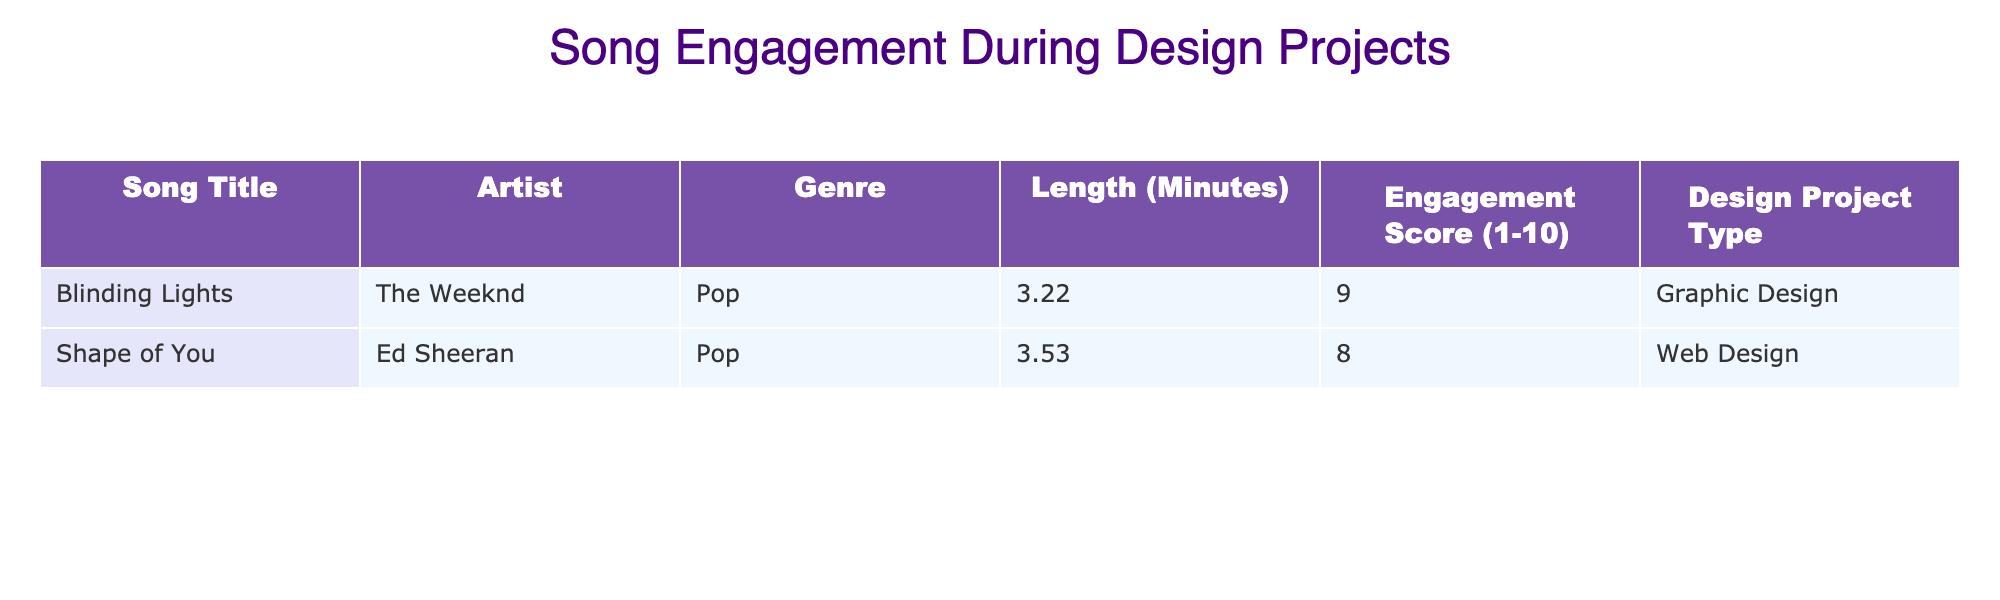What is the length of "Blinding Lights"? The table shows that the length of "Blinding Lights" is listed in the "Length (Minutes)" column, where it states 3.22 minutes.
Answer: 3.22 minutes What is the engagement score for "Shape of You"? Referring to the table, "Shape of You" has an engagement score of 8 according to the "Engagement Score (1-10)" column.
Answer: 8 Which song has a higher engagement score, "Blinding Lights" or "Shape of You"? Analyzing the engagement scores from the table, "Blinding Lights" has a score of 9, while "Shape of You" has a score of 8. Since 9 is greater than 8, "Blinding Lights" has a higher engagement score.
Answer: "Blinding Lights" What is the average length of the songs in the table? To find the average length, first sum the lengths of both songs: 3.22 + 3.53 = 6.75 minutes. Then, divide by the number of songs (2): 6.75 / 2 = 3.375 minutes.
Answer: 3.375 minutes Do both songs belong to the same genre? Checking the "Genre" column in the table, "Blinding Lights" is Pop, and "Shape of You" is also Pop. Since both are categorized as Pop, the answer is yes.
Answer: Yes What is the difference in engagement scores between the two songs? To find the difference, subtract the engagement score of "Shape of You" (8) from "Blinding Lights" (9): 9 - 8 = 1.
Answer: 1 Which design project type has a song with the highest engagement score? The highest engagement score is 9 for "Blinding Lights," which is associated with the design project type "Graphic Design." Since it's the only project type with that score, the answer is Graphic Design.
Answer: Graphic Design Is the length of "Shape of You" longer than 4 minutes? The table lists the length of "Shape of You" as 3.53 minutes. Since 3.53 is less than 4, the answer is no.
Answer: No 